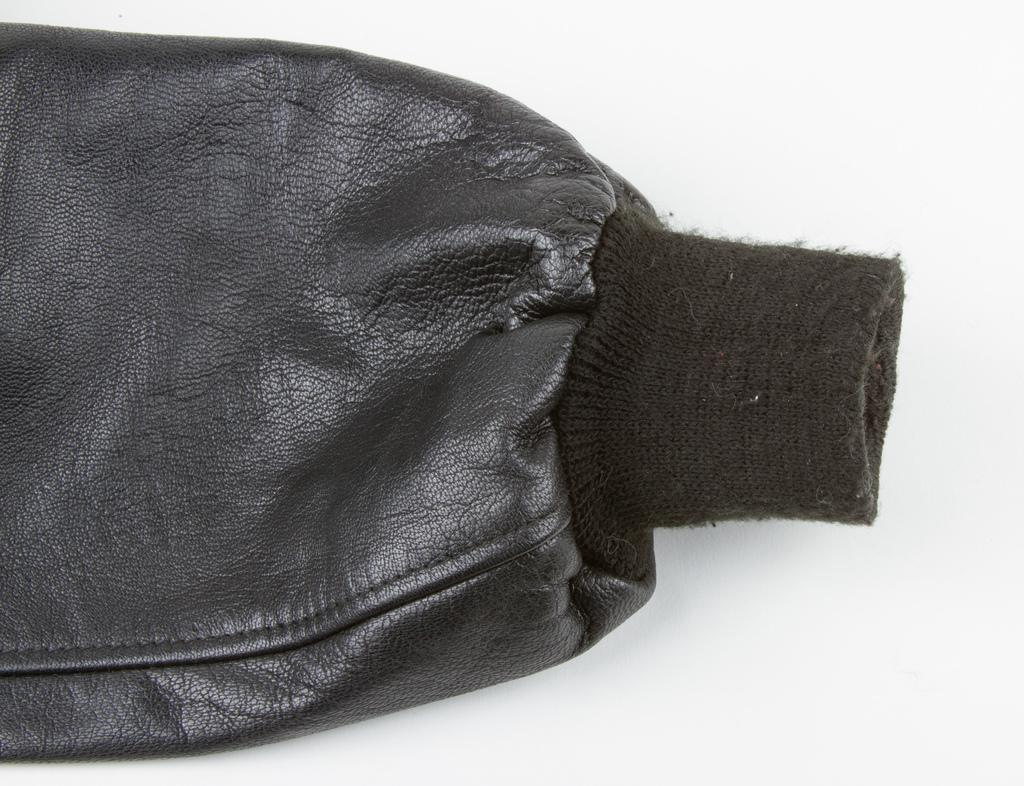What part of clothing can be seen in the image? There is a sleeve of a jacket in the image. How many teeth can be seen on the sleeve in the image? There are no teeth visible on the sleeve in the image, as it is a part of clothing and not a living organism. 